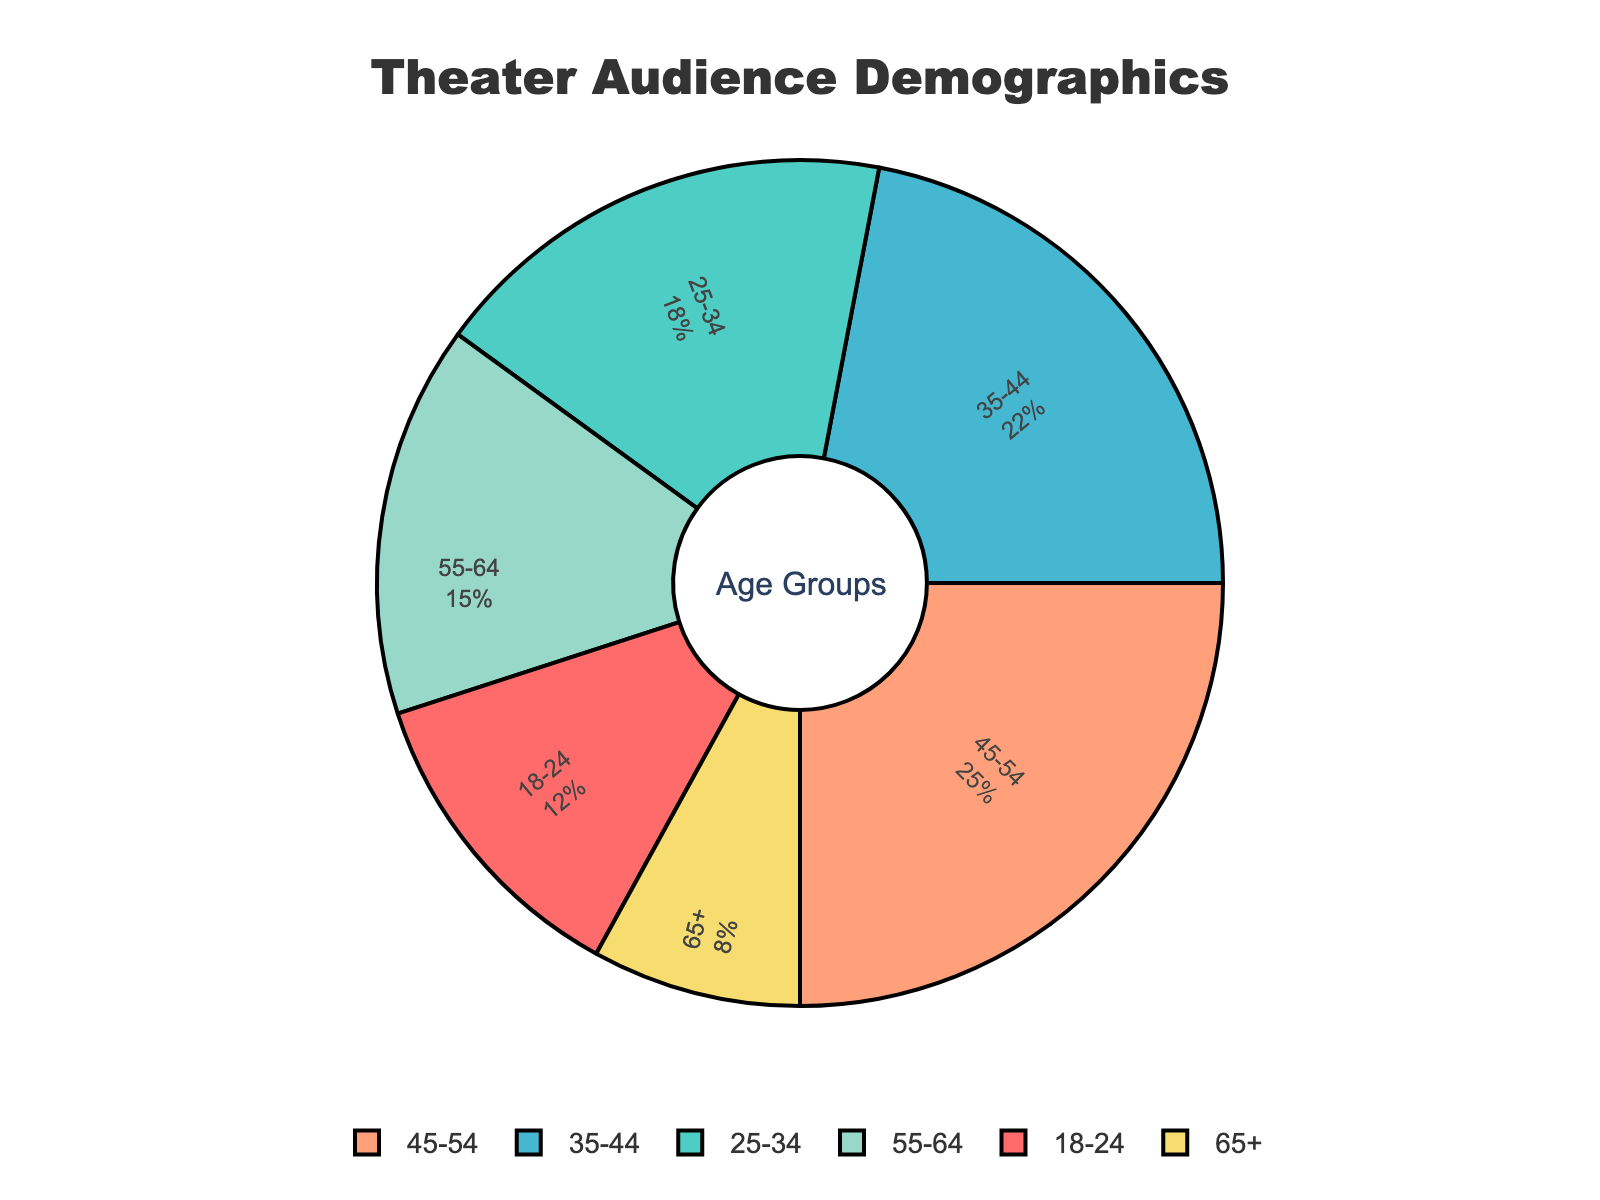What age group has the largest percentage of the audience? First, identify the percentage for each age group shown inside the slices of the pie chart. The age group with the largest value will be the one with the highest percentage. The age group 45-54 has the percentage value of 25%, which is the largest among all.
Answer: 45-54 How much larger is the percentage of the 45-54 age group compared to the 65+ age group? Locate the percentages for both 45-54 and 65+ age groups on the figure. Subtract the percentage of the 65+ group from the 45-54 group. For 45-54, it is 25%, and for 65+, it is 8%. The difference is 25% - 8% = 17%.
Answer: 17% What is the total percentage of theater audience members who are in the 35-54 age range? Add the percentages for the 35-44 and 45-54 age groups. For 35-44, it is 22%, and for 45-54, it is 25%. The total is 22% + 25% = 47%.
Answer: 47% Which age group has the smallest percentage of the audience, and what is the value? Identify the smallest value by comparing the percentages shown inside each slice of the pie chart. The age group 65+ has the smallest value, which is 8%.
Answer: 65+, 8% What percentage of the theater audience is 34 years old or younger? Add the percentages of the 18-24 and 25-34 age groups. For 18-24, it is 12%, and for 25-34, it is 18%. The total is 12% + 18% = 30%.
Answer: 30% Compare the percentages of the 25-34 and the 55-64 age groups. Which one is larger and by how much? Locate the percentages for the 25-34 and 55-64 age groups. For 25-34, it is 18%, and for 55-64, it is 15%. Subtract 15% from 18% to find the difference, 18% - 15% = 3%. The 25-34 age group is larger by 3%.
Answer: 25-34, 3% What is the total proportion of the audience in the age groups above 45? Add the percentages for the 45-54, 55-64, and 65+ age groups. For 45-54, it is 25%, for 55-64, it is 15%, and for 65+, it is 8%. The total is 25% + 15% + 8% = 48%.
Answer: 48% Which color represents the age group 35-44 in the figure? Look at the pie chart and identify the slice labeled 35-44, then note its color. The slice labeled 35-44 is represented by the color blue.
Answer: blue 